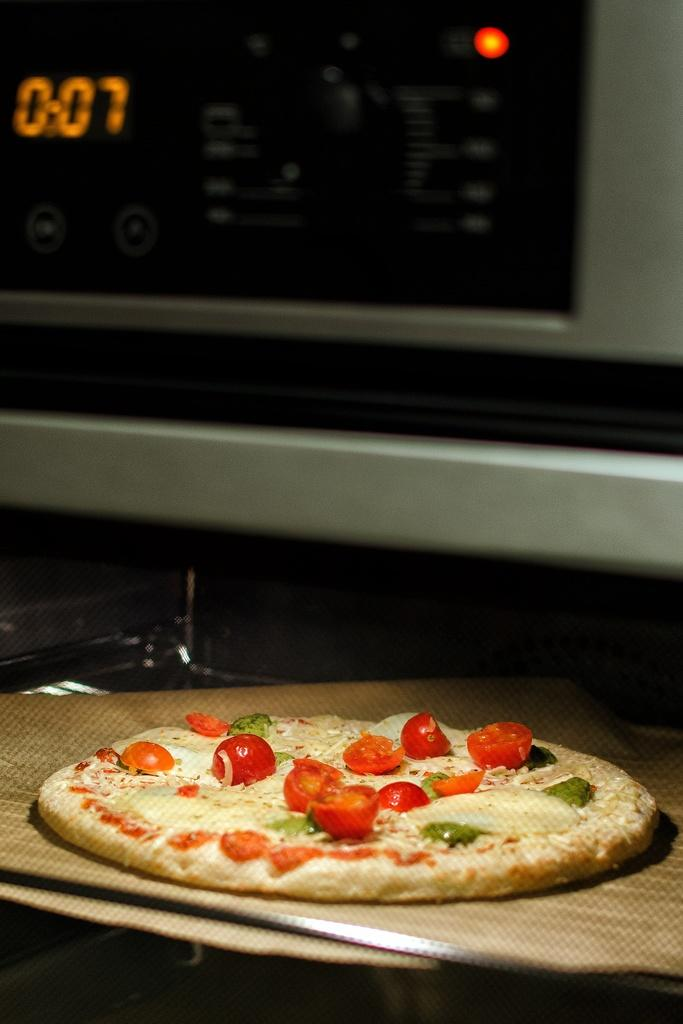<image>
Describe the image concisely. Pizza on a wooden board in front of a microwave at 0:07 seconds. 